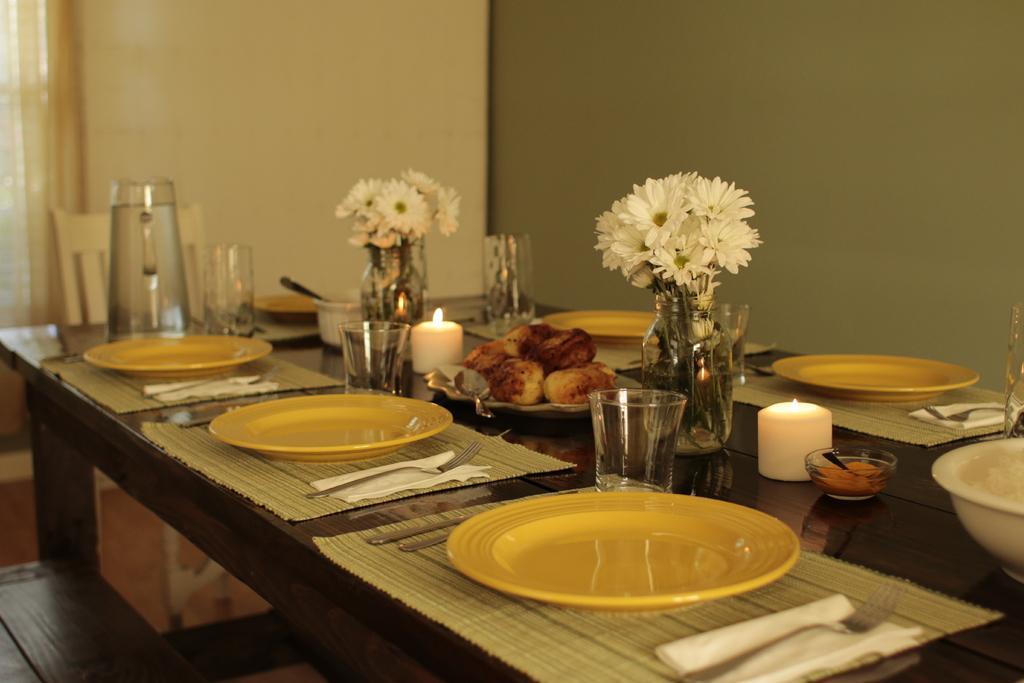Can you describe this image briefly? In this picture we can see table and on table we have plates, glasses, fork, spoon, candles, jar with flowers in it, some food item, tissue paper and in background we can see chair, wall, curtain. 